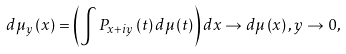<formula> <loc_0><loc_0><loc_500><loc_500>d \mu _ { y } \left ( x \right ) = \left ( \int P _ { x + i y } \left ( t \right ) d \mu \left ( t \right ) \right ) d x \rightarrow d \mu \left ( x \right ) , y \rightarrow 0 ,</formula> 